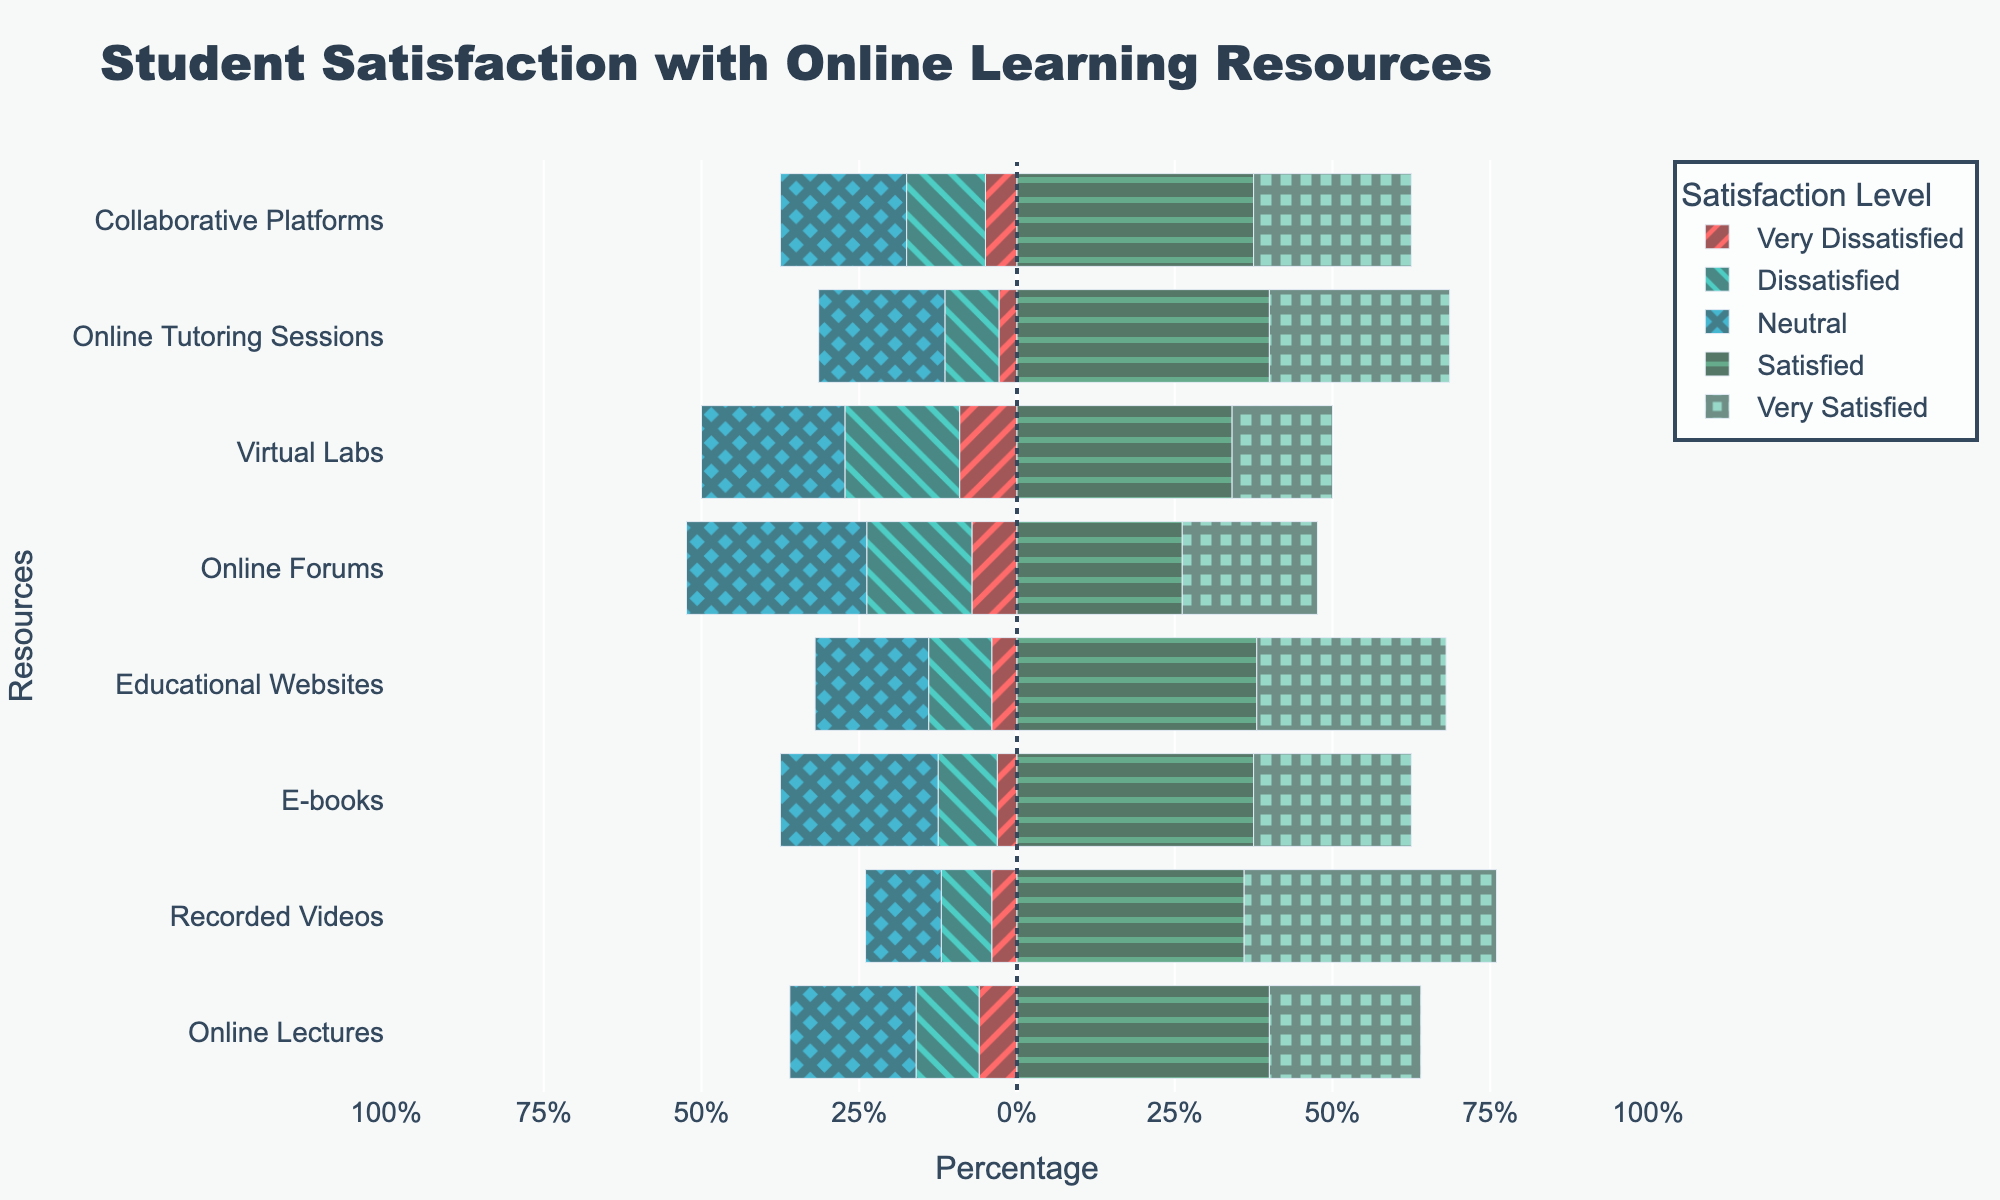Which online resource has the highest percentage of 'Very Satisfied' students? First, identify the bar segment representing 'Very Satisfied' for each resource. The 'Very Satisfied' bar that extends the furthest to the right indicates the highest percentage. According to the chart, 'Recorded Videos' shows the longest 'Very Satisfied' segment.
Answer: Recorded Videos Which online resource received the most dissatisfaction (sum of 'Very Dissatisfied' and 'Dissatisfied')? To find this, sum the ‘Very Dissatisfied’ and ‘Dissatisfied’ segments for each resource. The widest combined negative segment belongs to 'Virtual Labs'.
Answer: Virtual Labs Which resource has a higher percentage of 'Neutral' responses, 'Educational Websites' or 'Online Forums'? Compare the horizontal length of the 'Neutral' bar segments for 'Educational Websites' and 'Online Forums'. 'Online Forums' has a longer 'Neutral' bar.
Answer: Online Forums How many resources have 'Satisfied' responses greater than 25%? Look at the 'Satisfied' bar length for each resource and determine how many extend beyond the 25% mark. The 'Satisfied' bar for 'Online Lectures', 'Recorded Videos', 'Educational Websites', 'Virtual Labs', 'Online Tutoring Sessions', and 'Collaborative Platforms' exceeds 25%.
Answer: 6 Which resource has the smallest percentage of 'Very Dissatisfied' students? Identify the 'Very Dissatisfied' bar segment for each resource and find the smallest one. 'E-books' has the shortest 'Very Dissatisfied' segment.
Answer: E-books Is the percentage of 'Satisfied' students higher in 'Online Tutoring Sessions' or in 'Online Lectures'? Compare the horizontal length of the 'Satisfied' bar for both 'Online Tutoring Sessions' and 'Online Lectures'. The 'Satisfied' bar for 'Online Lectures' is longer.
Answer: Online Lectures What is the combined percentage of 'Neutral' and 'Dissatisfied' responses for 'Recorded Videos'? Measure the length of 'Neutral' and 'Dissatisfied' bars for 'Recorded Videos' and sum their percentages. 'Neutral' is 15% and 'Dissatisfied' is around 10%, so the combined is 25%.
Answer: 25% Which resource has more students either 'Satisfied' or 'Very Satisfied': 'Collaborative Platforms' or 'Virtual Labs'? Add the percentages of 'Satisfied' and 'Very Satisfied' for both 'Collaborative Platforms' and 'Virtual Labs'. For 'Collaborative Platforms', it is around 45%, and for 'Virtual Labs' it is around 35%.
Answer: Collaborative Platforms What is the most common satisfaction level for 'Online Forums'? Identify the bar segment that extends the furthest to the right among ratings for 'Online Forums'. The 'Neutral' bar is the longest.
Answer: Neutral How does the sum of 'Satisfied' and 'Very Satisfied' percentages for 'E-books' compare to the same sum for 'Educational Websites'? Sum the 'Satisfied' and 'Very Satisfied' percentages for both 'E-books' and 'Educational Websites'. 'E-books' has around 45% combined, and 'Educational Websites' has around 55%.
Answer: Educational Websites 